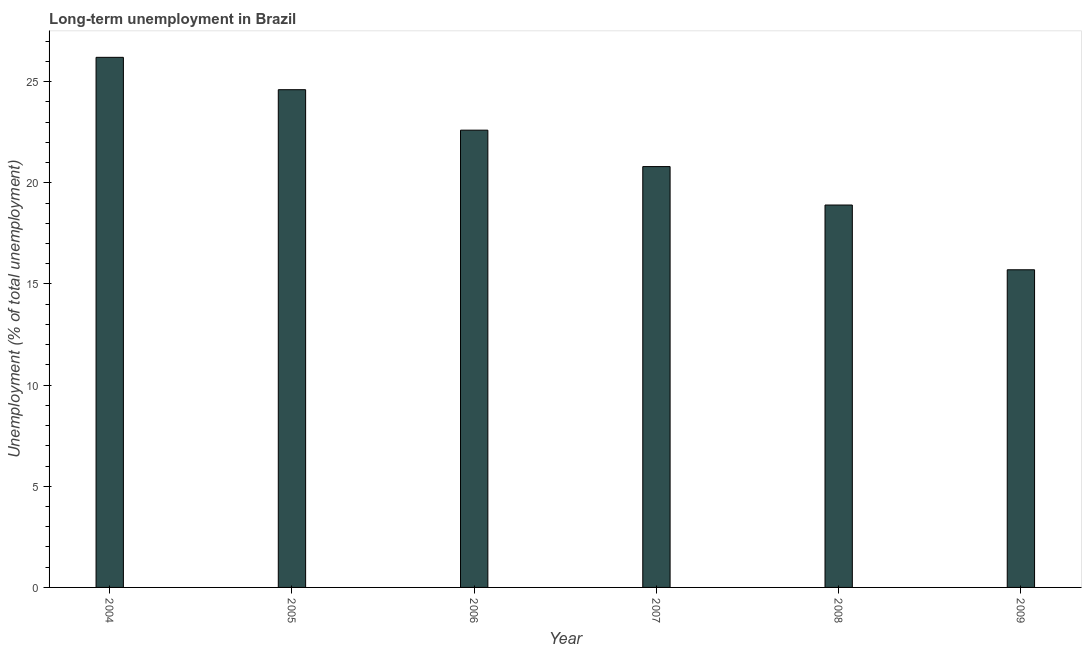What is the title of the graph?
Offer a very short reply. Long-term unemployment in Brazil. What is the label or title of the Y-axis?
Provide a short and direct response. Unemployment (% of total unemployment). What is the long-term unemployment in 2007?
Your response must be concise. 20.8. Across all years, what is the maximum long-term unemployment?
Provide a succinct answer. 26.2. Across all years, what is the minimum long-term unemployment?
Keep it short and to the point. 15.7. In which year was the long-term unemployment maximum?
Offer a terse response. 2004. In which year was the long-term unemployment minimum?
Give a very brief answer. 2009. What is the sum of the long-term unemployment?
Provide a short and direct response. 128.8. What is the difference between the long-term unemployment in 2004 and 2007?
Offer a terse response. 5.4. What is the average long-term unemployment per year?
Provide a succinct answer. 21.47. What is the median long-term unemployment?
Give a very brief answer. 21.7. In how many years, is the long-term unemployment greater than 5 %?
Your response must be concise. 6. What is the ratio of the long-term unemployment in 2004 to that in 2005?
Your answer should be very brief. 1.06. Is the sum of the long-term unemployment in 2004 and 2009 greater than the maximum long-term unemployment across all years?
Provide a succinct answer. Yes. What is the difference between the highest and the lowest long-term unemployment?
Provide a succinct answer. 10.5. How many bars are there?
Provide a succinct answer. 6. Are all the bars in the graph horizontal?
Offer a very short reply. No. How many years are there in the graph?
Provide a short and direct response. 6. What is the difference between two consecutive major ticks on the Y-axis?
Give a very brief answer. 5. What is the Unemployment (% of total unemployment) in 2004?
Give a very brief answer. 26.2. What is the Unemployment (% of total unemployment) in 2005?
Give a very brief answer. 24.6. What is the Unemployment (% of total unemployment) of 2006?
Provide a short and direct response. 22.6. What is the Unemployment (% of total unemployment) in 2007?
Provide a short and direct response. 20.8. What is the Unemployment (% of total unemployment) of 2008?
Provide a succinct answer. 18.9. What is the Unemployment (% of total unemployment) in 2009?
Ensure brevity in your answer.  15.7. What is the difference between the Unemployment (% of total unemployment) in 2004 and 2006?
Your answer should be compact. 3.6. What is the difference between the Unemployment (% of total unemployment) in 2004 and 2007?
Provide a succinct answer. 5.4. What is the difference between the Unemployment (% of total unemployment) in 2004 and 2008?
Offer a terse response. 7.3. What is the difference between the Unemployment (% of total unemployment) in 2004 and 2009?
Your answer should be compact. 10.5. What is the difference between the Unemployment (% of total unemployment) in 2005 and 2007?
Ensure brevity in your answer.  3.8. What is the difference between the Unemployment (% of total unemployment) in 2006 and 2007?
Your answer should be compact. 1.8. What is the difference between the Unemployment (% of total unemployment) in 2006 and 2008?
Offer a very short reply. 3.7. What is the difference between the Unemployment (% of total unemployment) in 2006 and 2009?
Ensure brevity in your answer.  6.9. What is the difference between the Unemployment (% of total unemployment) in 2007 and 2009?
Give a very brief answer. 5.1. What is the ratio of the Unemployment (% of total unemployment) in 2004 to that in 2005?
Offer a very short reply. 1.06. What is the ratio of the Unemployment (% of total unemployment) in 2004 to that in 2006?
Keep it short and to the point. 1.16. What is the ratio of the Unemployment (% of total unemployment) in 2004 to that in 2007?
Your response must be concise. 1.26. What is the ratio of the Unemployment (% of total unemployment) in 2004 to that in 2008?
Keep it short and to the point. 1.39. What is the ratio of the Unemployment (% of total unemployment) in 2004 to that in 2009?
Keep it short and to the point. 1.67. What is the ratio of the Unemployment (% of total unemployment) in 2005 to that in 2006?
Offer a terse response. 1.09. What is the ratio of the Unemployment (% of total unemployment) in 2005 to that in 2007?
Give a very brief answer. 1.18. What is the ratio of the Unemployment (% of total unemployment) in 2005 to that in 2008?
Make the answer very short. 1.3. What is the ratio of the Unemployment (% of total unemployment) in 2005 to that in 2009?
Provide a succinct answer. 1.57. What is the ratio of the Unemployment (% of total unemployment) in 2006 to that in 2007?
Provide a succinct answer. 1.09. What is the ratio of the Unemployment (% of total unemployment) in 2006 to that in 2008?
Your answer should be very brief. 1.2. What is the ratio of the Unemployment (% of total unemployment) in 2006 to that in 2009?
Your response must be concise. 1.44. What is the ratio of the Unemployment (% of total unemployment) in 2007 to that in 2008?
Provide a succinct answer. 1.1. What is the ratio of the Unemployment (% of total unemployment) in 2007 to that in 2009?
Provide a short and direct response. 1.32. What is the ratio of the Unemployment (% of total unemployment) in 2008 to that in 2009?
Make the answer very short. 1.2. 